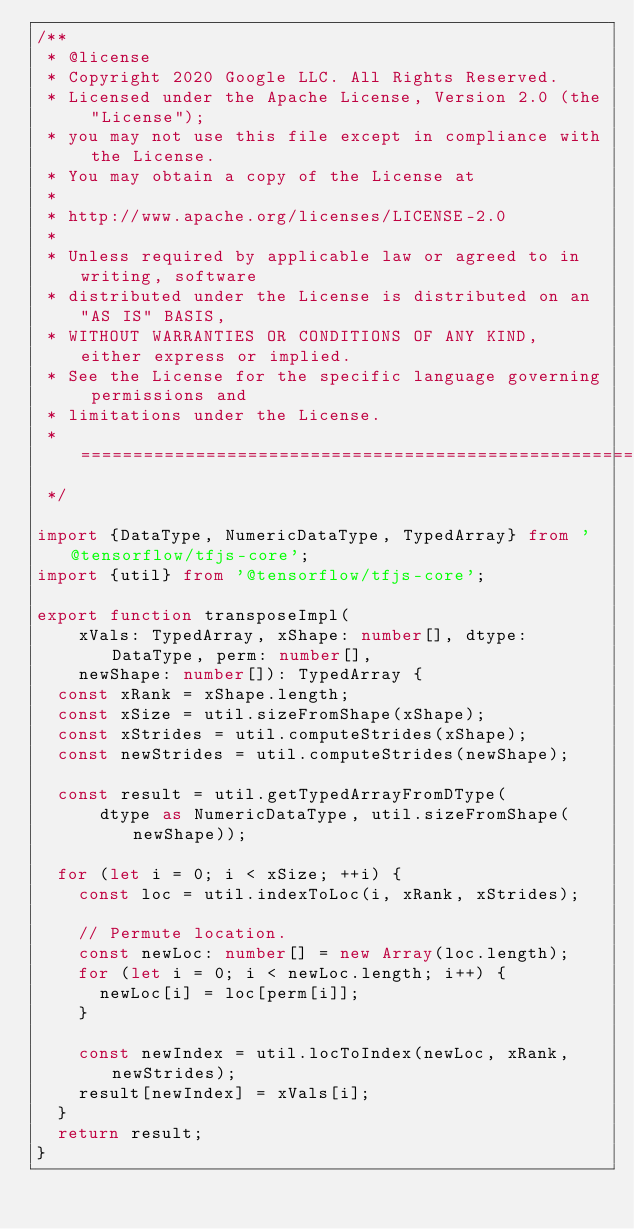Convert code to text. <code><loc_0><loc_0><loc_500><loc_500><_TypeScript_>/**
 * @license
 * Copyright 2020 Google LLC. All Rights Reserved.
 * Licensed under the Apache License, Version 2.0 (the "License");
 * you may not use this file except in compliance with the License.
 * You may obtain a copy of the License at
 *
 * http://www.apache.org/licenses/LICENSE-2.0
 *
 * Unless required by applicable law or agreed to in writing, software
 * distributed under the License is distributed on an "AS IS" BASIS,
 * WITHOUT WARRANTIES OR CONDITIONS OF ANY KIND, either express or implied.
 * See the License for the specific language governing permissions and
 * limitations under the License.
 * =============================================================================
 */

import {DataType, NumericDataType, TypedArray} from '@tensorflow/tfjs-core';
import {util} from '@tensorflow/tfjs-core';

export function transposeImpl(
    xVals: TypedArray, xShape: number[], dtype: DataType, perm: number[],
    newShape: number[]): TypedArray {
  const xRank = xShape.length;
  const xSize = util.sizeFromShape(xShape);
  const xStrides = util.computeStrides(xShape);
  const newStrides = util.computeStrides(newShape);

  const result = util.getTypedArrayFromDType(
      dtype as NumericDataType, util.sizeFromShape(newShape));

  for (let i = 0; i < xSize; ++i) {
    const loc = util.indexToLoc(i, xRank, xStrides);

    // Permute location.
    const newLoc: number[] = new Array(loc.length);
    for (let i = 0; i < newLoc.length; i++) {
      newLoc[i] = loc[perm[i]];
    }

    const newIndex = util.locToIndex(newLoc, xRank, newStrides);
    result[newIndex] = xVals[i];
  }
  return result;
}
</code> 